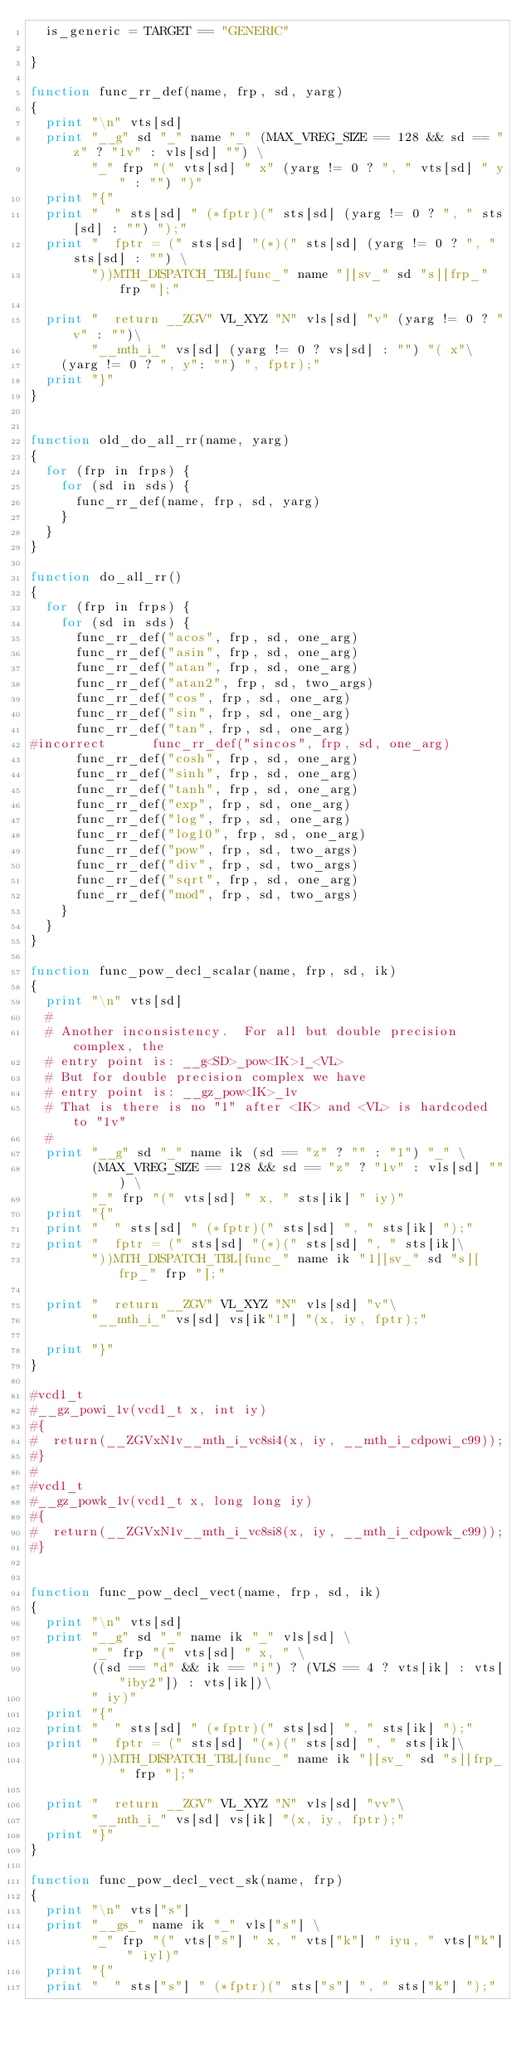<code> <loc_0><loc_0><loc_500><loc_500><_Awk_>  is_generic = TARGET == "GENERIC"

}

function func_rr_def(name, frp, sd, yarg)
{
  print "\n" vts[sd]
  print "__g" sd "_" name "_" (MAX_VREG_SIZE == 128 && sd == "z" ? "1v" : vls[sd] "") \
        "_" frp "(" vts[sd] " x" (yarg != 0 ? ", " vts[sd] " y" : "") ")"
  print "{"
  print "  " sts[sd] " (*fptr)(" sts[sd] (yarg != 0 ? ", " sts[sd] : "") ");"
  print "  fptr = (" sts[sd] "(*)(" sts[sd] (yarg != 0 ? ", " sts[sd] : "") \
        "))MTH_DISPATCH_TBL[func_" name "][sv_" sd "s][frp_" frp "];"

  print "  return __ZGV" VL_XYZ "N" vls[sd] "v" (yarg != 0 ? "v" : "")\
        "__mth_i_" vs[sd] (yarg != 0 ? vs[sd] : "") "( x"\
	(yarg != 0 ? ", y": "") ", fptr);"
  print "}"
}


function old_do_all_rr(name, yarg)
{
  for (frp in frps) {
    for (sd in sds) {
      func_rr_def(name, frp, sd, yarg)
    }
  }
}

function do_all_rr()
{
  for (frp in frps) {
    for (sd in sds) {
      func_rr_def("acos", frp, sd, one_arg)
      func_rr_def("asin", frp, sd, one_arg)
      func_rr_def("atan", frp, sd, one_arg)
      func_rr_def("atan2", frp, sd, two_args)
      func_rr_def("cos", frp, sd, one_arg)
      func_rr_def("sin", frp, sd, one_arg)
      func_rr_def("tan", frp, sd, one_arg)
#incorrect      func_rr_def("sincos", frp, sd, one_arg)
      func_rr_def("cosh", frp, sd, one_arg)
      func_rr_def("sinh", frp, sd, one_arg)
      func_rr_def("tanh", frp, sd, one_arg)
      func_rr_def("exp", frp, sd, one_arg)
      func_rr_def("log", frp, sd, one_arg)
      func_rr_def("log10", frp, sd, one_arg)
      func_rr_def("pow", frp, sd, two_args)
      func_rr_def("div", frp, sd, two_args)
      func_rr_def("sqrt", frp, sd, one_arg)
      func_rr_def("mod", frp, sd, two_args)
    }
  }
}

function func_pow_decl_scalar(name, frp, sd, ik)
{
  print "\n" vts[sd]
  #
  # Another inconsistency.  For all but double precision complex, the
  # entry point is: __g<SD>_pow<IK>1_<VL>
  # But for double precision complex we have
  # entry point is: __gz_pow<IK>_1v
  # That is there is no "1" after <IK> and <VL> is hardcoded to "1v"
  #
  print "__g" sd "_" name ik (sd == "z" ? "" : "1") "_" \
        (MAX_VREG_SIZE == 128 && sd == "z" ? "1v" : vls[sd] "") \
        "_" frp "(" vts[sd] " x, " sts[ik] " iy)"
  print "{"
  print "  " sts[sd] " (*fptr)(" sts[sd] ", " sts[ik] ");"
  print "  fptr = (" sts[sd] "(*)(" sts[sd] ", " sts[ik]\
        "))MTH_DISPATCH_TBL[func_" name ik "1][sv_" sd "s][frp_" frp "];"

  print "  return __ZGV" VL_XYZ "N" vls[sd] "v"\
        "__mth_i_" vs[sd] vs[ik"1"] "(x, iy, fptr);"
	
  print "}"
}

#vcd1_t
#__gz_powi_1v(vcd1_t x, int iy)
#{
#  return(__ZGVxN1v__mth_i_vc8si4(x, iy, __mth_i_cdpowi_c99));
#}
#
#vcd1_t
#__gz_powk_1v(vcd1_t x, long long iy)
#{
#  return(__ZGVxN1v__mth_i_vc8si8(x, iy, __mth_i_cdpowk_c99));
#}


function func_pow_decl_vect(name, frp, sd, ik)
{
  print "\n" vts[sd]
  print "__g" sd "_" name ik "_" vls[sd] \
        "_" frp "(" vts[sd] " x, " \
        ((sd == "d" && ik == "i") ? (VLS == 4 ? vts[ik] : vts["iby2"]) : vts[ik])\
        " iy)"
  print "{"
  print "  " sts[sd] " (*fptr)(" sts[sd] ", " sts[ik] ");"
  print "  fptr = (" sts[sd] "(*)(" sts[sd] ", " sts[ik]\
        "))MTH_DISPATCH_TBL[func_" name ik "][sv_" sd "s][frp_" frp "];"

  print "  return __ZGV" VL_XYZ "N" vls[sd] "vv"\
        "__mth_i_" vs[sd] vs[ik] "(x, iy, fptr);"
  print "}"
}

function func_pow_decl_vect_sk(name, frp)
{
  print "\n" vts["s"]
  print "__gs_" name ik "_" vls["s"] \
        "_" frp "(" vts["s"] " x, " vts["k"] " iyu, " vts["k"] " iyl)"
  print "{"
  print "  " sts["s"] " (*fptr)(" sts["s"] ", " sts["k"] ");"</code> 